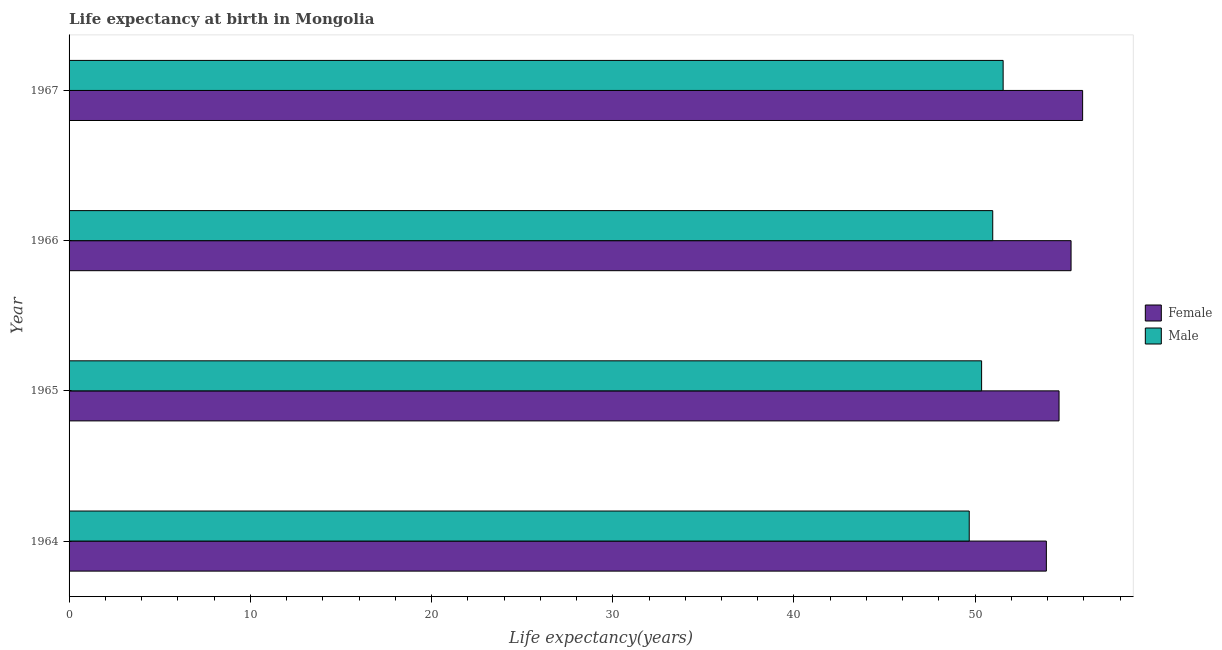How many different coloured bars are there?
Offer a terse response. 2. How many groups of bars are there?
Give a very brief answer. 4. What is the label of the 2nd group of bars from the top?
Provide a short and direct response. 1966. What is the life expectancy(male) in 1964?
Give a very brief answer. 49.67. Across all years, what is the maximum life expectancy(female)?
Offer a very short reply. 55.93. Across all years, what is the minimum life expectancy(female)?
Your answer should be very brief. 53.93. In which year was the life expectancy(female) maximum?
Keep it short and to the point. 1967. In which year was the life expectancy(male) minimum?
Provide a short and direct response. 1964. What is the total life expectancy(female) in the graph?
Keep it short and to the point. 219.77. What is the difference between the life expectancy(male) in 1964 and that in 1966?
Offer a very short reply. -1.3. What is the difference between the life expectancy(male) in 1967 and the life expectancy(female) in 1964?
Provide a short and direct response. -2.39. What is the average life expectancy(female) per year?
Your response must be concise. 54.94. In the year 1966, what is the difference between the life expectancy(male) and life expectancy(female)?
Provide a short and direct response. -4.32. In how many years, is the life expectancy(female) greater than 26 years?
Offer a very short reply. 4. Is the difference between the life expectancy(female) in 1964 and 1967 greater than the difference between the life expectancy(male) in 1964 and 1967?
Offer a terse response. No. What is the difference between the highest and the second highest life expectancy(female)?
Your response must be concise. 0.64. What is the difference between the highest and the lowest life expectancy(female)?
Keep it short and to the point. 2. Is the sum of the life expectancy(male) in 1964 and 1965 greater than the maximum life expectancy(female) across all years?
Keep it short and to the point. Yes. How many bars are there?
Your answer should be very brief. 8. What is the difference between two consecutive major ticks on the X-axis?
Make the answer very short. 10. Are the values on the major ticks of X-axis written in scientific E-notation?
Ensure brevity in your answer.  No. Does the graph contain any zero values?
Offer a very short reply. No. How many legend labels are there?
Make the answer very short. 2. How are the legend labels stacked?
Your response must be concise. Vertical. What is the title of the graph?
Your answer should be very brief. Life expectancy at birth in Mongolia. What is the label or title of the X-axis?
Provide a short and direct response. Life expectancy(years). What is the label or title of the Y-axis?
Keep it short and to the point. Year. What is the Life expectancy(years) of Female in 1964?
Make the answer very short. 53.93. What is the Life expectancy(years) of Male in 1964?
Offer a very short reply. 49.67. What is the Life expectancy(years) in Female in 1965?
Ensure brevity in your answer.  54.63. What is the Life expectancy(years) in Male in 1965?
Offer a terse response. 50.35. What is the Life expectancy(years) of Female in 1966?
Offer a terse response. 55.29. What is the Life expectancy(years) of Male in 1966?
Provide a short and direct response. 50.97. What is the Life expectancy(years) in Female in 1967?
Provide a short and direct response. 55.93. What is the Life expectancy(years) in Male in 1967?
Provide a succinct answer. 51.54. Across all years, what is the maximum Life expectancy(years) of Female?
Offer a very short reply. 55.93. Across all years, what is the maximum Life expectancy(years) of Male?
Make the answer very short. 51.54. Across all years, what is the minimum Life expectancy(years) of Female?
Provide a short and direct response. 53.93. Across all years, what is the minimum Life expectancy(years) of Male?
Make the answer very short. 49.67. What is the total Life expectancy(years) in Female in the graph?
Offer a terse response. 219.77. What is the total Life expectancy(years) of Male in the graph?
Your answer should be compact. 202.53. What is the difference between the Life expectancy(years) of Male in 1964 and that in 1965?
Provide a short and direct response. -0.68. What is the difference between the Life expectancy(years) in Female in 1964 and that in 1966?
Make the answer very short. -1.36. What is the difference between the Life expectancy(years) of Male in 1964 and that in 1966?
Your answer should be very brief. -1.3. What is the difference between the Life expectancy(years) in Female in 1964 and that in 1967?
Your answer should be compact. -2. What is the difference between the Life expectancy(years) in Male in 1964 and that in 1967?
Offer a very short reply. -1.87. What is the difference between the Life expectancy(years) of Female in 1965 and that in 1966?
Your response must be concise. -0.66. What is the difference between the Life expectancy(years) of Male in 1965 and that in 1966?
Ensure brevity in your answer.  -0.61. What is the difference between the Life expectancy(years) of Female in 1965 and that in 1967?
Keep it short and to the point. -1.3. What is the difference between the Life expectancy(years) of Male in 1965 and that in 1967?
Your response must be concise. -1.19. What is the difference between the Life expectancy(years) of Female in 1966 and that in 1967?
Ensure brevity in your answer.  -0.64. What is the difference between the Life expectancy(years) in Male in 1966 and that in 1967?
Offer a terse response. -0.57. What is the difference between the Life expectancy(years) of Female in 1964 and the Life expectancy(years) of Male in 1965?
Ensure brevity in your answer.  3.57. What is the difference between the Life expectancy(years) in Female in 1964 and the Life expectancy(years) in Male in 1966?
Your answer should be very brief. 2.96. What is the difference between the Life expectancy(years) in Female in 1964 and the Life expectancy(years) in Male in 1967?
Provide a succinct answer. 2.38. What is the difference between the Life expectancy(years) in Female in 1965 and the Life expectancy(years) in Male in 1966?
Offer a very short reply. 3.66. What is the difference between the Life expectancy(years) in Female in 1965 and the Life expectancy(years) in Male in 1967?
Keep it short and to the point. 3.08. What is the difference between the Life expectancy(years) in Female in 1966 and the Life expectancy(years) in Male in 1967?
Give a very brief answer. 3.75. What is the average Life expectancy(years) of Female per year?
Your response must be concise. 54.94. What is the average Life expectancy(years) of Male per year?
Offer a very short reply. 50.63. In the year 1964, what is the difference between the Life expectancy(years) of Female and Life expectancy(years) of Male?
Offer a terse response. 4.26. In the year 1965, what is the difference between the Life expectancy(years) in Female and Life expectancy(years) in Male?
Ensure brevity in your answer.  4.27. In the year 1966, what is the difference between the Life expectancy(years) in Female and Life expectancy(years) in Male?
Your response must be concise. 4.32. In the year 1967, what is the difference between the Life expectancy(years) in Female and Life expectancy(years) in Male?
Offer a terse response. 4.39. What is the ratio of the Life expectancy(years) of Female in 1964 to that in 1965?
Your response must be concise. 0.99. What is the ratio of the Life expectancy(years) of Male in 1964 to that in 1965?
Keep it short and to the point. 0.99. What is the ratio of the Life expectancy(years) in Female in 1964 to that in 1966?
Your answer should be compact. 0.98. What is the ratio of the Life expectancy(years) of Male in 1964 to that in 1966?
Make the answer very short. 0.97. What is the ratio of the Life expectancy(years) in Female in 1964 to that in 1967?
Your response must be concise. 0.96. What is the ratio of the Life expectancy(years) of Male in 1964 to that in 1967?
Ensure brevity in your answer.  0.96. What is the ratio of the Life expectancy(years) of Female in 1965 to that in 1967?
Offer a very short reply. 0.98. What is the ratio of the Life expectancy(years) in Male in 1965 to that in 1967?
Give a very brief answer. 0.98. What is the ratio of the Life expectancy(years) in Female in 1966 to that in 1967?
Make the answer very short. 0.99. What is the ratio of the Life expectancy(years) of Male in 1966 to that in 1967?
Ensure brevity in your answer.  0.99. What is the difference between the highest and the second highest Life expectancy(years) of Female?
Your response must be concise. 0.64. What is the difference between the highest and the second highest Life expectancy(years) in Male?
Provide a short and direct response. 0.57. What is the difference between the highest and the lowest Life expectancy(years) of Female?
Make the answer very short. 2. What is the difference between the highest and the lowest Life expectancy(years) of Male?
Ensure brevity in your answer.  1.87. 